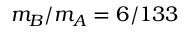Convert formula to latex. <formula><loc_0><loc_0><loc_500><loc_500>m _ { B } / m _ { A } = 6 / 1 3 3</formula> 